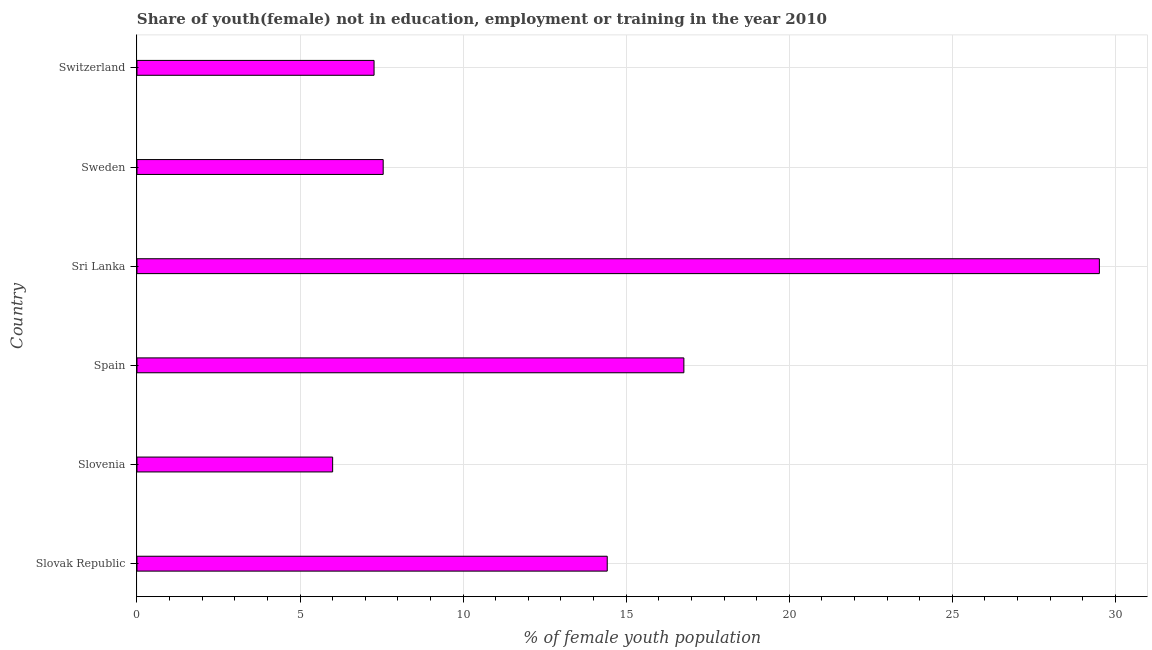What is the title of the graph?
Make the answer very short. Share of youth(female) not in education, employment or training in the year 2010. What is the label or title of the X-axis?
Provide a short and direct response. % of female youth population. What is the label or title of the Y-axis?
Provide a succinct answer. Country. What is the unemployed female youth population in Switzerland?
Your response must be concise. 7.27. Across all countries, what is the maximum unemployed female youth population?
Keep it short and to the point. 29.51. In which country was the unemployed female youth population maximum?
Provide a succinct answer. Sri Lanka. In which country was the unemployed female youth population minimum?
Keep it short and to the point. Slovenia. What is the sum of the unemployed female youth population?
Offer a terse response. 81.52. What is the difference between the unemployed female youth population in Spain and Switzerland?
Keep it short and to the point. 9.5. What is the average unemployed female youth population per country?
Keep it short and to the point. 13.59. What is the median unemployed female youth population?
Provide a short and direct response. 10.99. In how many countries, is the unemployed female youth population greater than 24 %?
Your answer should be compact. 1. What is the ratio of the unemployed female youth population in Sri Lanka to that in Sweden?
Provide a short and direct response. 3.91. Is the unemployed female youth population in Slovenia less than that in Switzerland?
Your answer should be very brief. Yes. Is the difference between the unemployed female youth population in Slovenia and Spain greater than the difference between any two countries?
Provide a succinct answer. No. What is the difference between the highest and the second highest unemployed female youth population?
Your response must be concise. 12.74. What is the difference between the highest and the lowest unemployed female youth population?
Give a very brief answer. 23.51. In how many countries, is the unemployed female youth population greater than the average unemployed female youth population taken over all countries?
Offer a terse response. 3. How many countries are there in the graph?
Keep it short and to the point. 6. What is the difference between two consecutive major ticks on the X-axis?
Ensure brevity in your answer.  5. What is the % of female youth population in Slovak Republic?
Provide a succinct answer. 14.42. What is the % of female youth population in Slovenia?
Make the answer very short. 6. What is the % of female youth population of Spain?
Your answer should be compact. 16.77. What is the % of female youth population of Sri Lanka?
Provide a short and direct response. 29.51. What is the % of female youth population in Sweden?
Your answer should be very brief. 7.55. What is the % of female youth population in Switzerland?
Your answer should be compact. 7.27. What is the difference between the % of female youth population in Slovak Republic and Slovenia?
Provide a succinct answer. 8.42. What is the difference between the % of female youth population in Slovak Republic and Spain?
Your answer should be very brief. -2.35. What is the difference between the % of female youth population in Slovak Republic and Sri Lanka?
Offer a terse response. -15.09. What is the difference between the % of female youth population in Slovak Republic and Sweden?
Your answer should be very brief. 6.87. What is the difference between the % of female youth population in Slovak Republic and Switzerland?
Offer a terse response. 7.15. What is the difference between the % of female youth population in Slovenia and Spain?
Offer a terse response. -10.77. What is the difference between the % of female youth population in Slovenia and Sri Lanka?
Your response must be concise. -23.51. What is the difference between the % of female youth population in Slovenia and Sweden?
Keep it short and to the point. -1.55. What is the difference between the % of female youth population in Slovenia and Switzerland?
Ensure brevity in your answer.  -1.27. What is the difference between the % of female youth population in Spain and Sri Lanka?
Offer a very short reply. -12.74. What is the difference between the % of female youth population in Spain and Sweden?
Provide a short and direct response. 9.22. What is the difference between the % of female youth population in Sri Lanka and Sweden?
Offer a terse response. 21.96. What is the difference between the % of female youth population in Sri Lanka and Switzerland?
Provide a succinct answer. 22.24. What is the difference between the % of female youth population in Sweden and Switzerland?
Ensure brevity in your answer.  0.28. What is the ratio of the % of female youth population in Slovak Republic to that in Slovenia?
Offer a terse response. 2.4. What is the ratio of the % of female youth population in Slovak Republic to that in Spain?
Make the answer very short. 0.86. What is the ratio of the % of female youth population in Slovak Republic to that in Sri Lanka?
Offer a very short reply. 0.49. What is the ratio of the % of female youth population in Slovak Republic to that in Sweden?
Provide a succinct answer. 1.91. What is the ratio of the % of female youth population in Slovak Republic to that in Switzerland?
Keep it short and to the point. 1.98. What is the ratio of the % of female youth population in Slovenia to that in Spain?
Ensure brevity in your answer.  0.36. What is the ratio of the % of female youth population in Slovenia to that in Sri Lanka?
Give a very brief answer. 0.2. What is the ratio of the % of female youth population in Slovenia to that in Sweden?
Give a very brief answer. 0.8. What is the ratio of the % of female youth population in Slovenia to that in Switzerland?
Your response must be concise. 0.82. What is the ratio of the % of female youth population in Spain to that in Sri Lanka?
Your answer should be very brief. 0.57. What is the ratio of the % of female youth population in Spain to that in Sweden?
Provide a succinct answer. 2.22. What is the ratio of the % of female youth population in Spain to that in Switzerland?
Make the answer very short. 2.31. What is the ratio of the % of female youth population in Sri Lanka to that in Sweden?
Give a very brief answer. 3.91. What is the ratio of the % of female youth population in Sri Lanka to that in Switzerland?
Provide a short and direct response. 4.06. What is the ratio of the % of female youth population in Sweden to that in Switzerland?
Offer a very short reply. 1.04. 